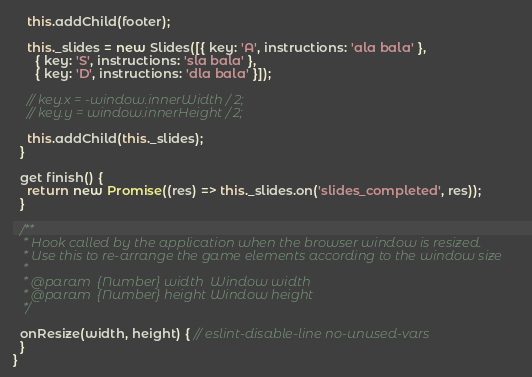Convert code to text. <code><loc_0><loc_0><loc_500><loc_500><_JavaScript_>    this.addChild(footer);

    this._slides = new Slides([{ key: 'A', instructions: 'ala bala' },
      { key: 'S', instructions: 'sla bala' },
      { key: 'D', instructions: 'dla bala' }]);

    // key.x = -window.innerWidth / 2;
    // key.y = window.innerHeight / 2;

    this.addChild(this._slides);
  }

  get finish() {
    return new Promise((res) => this._slides.on('slides_completed', res));
  }

  /**
   * Hook called by the application when the browser window is resized.
   * Use this to re-arrange the game elements according to the window size
   *
   * @param  {Number} width  Window width
   * @param  {Number} height Window height
   */
  
  onResize(width, height) { // eslint-disable-line no-unused-vars
  }
}
</code> 